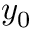<formula> <loc_0><loc_0><loc_500><loc_500>y _ { 0 }</formula> 